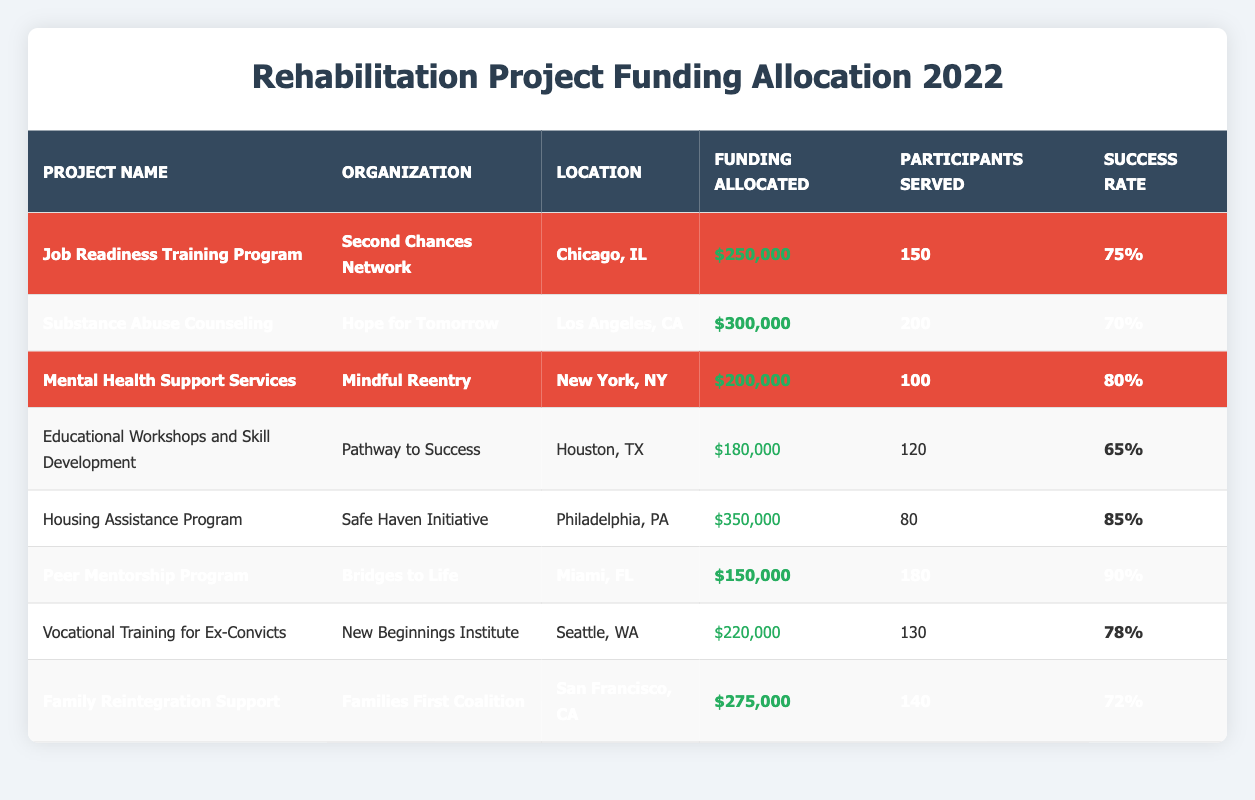What is the total funding allocated to the highlighted projects? The highlighted projects are: Job Readiness Training Program ($250,000), Substance Abuse Counseling ($300,000), Mental Health Support Services ($200,000), Peer Mentorship Program ($150,000), and Family Reintegration Support ($275,000). Adding these amounts gives: 250,000 + 300,000 + 200,000 + 150,000 + 275,000 = $1,175,000.
Answer: $1,175,000 Which project has the highest success rate? Looking at the success rates listed for all projects, the Peer Mentorship Program has the highest rate at 90%.
Answer: Peer Mentorship Program How many participants were served in total by the highlighted projects? The highlighted projects served: 150 (Job Readiness) + 200 (Substance Abuse) + 100 (Mental Health) + 180 (Peer Mentorship) + 140 (Family Reintegration) = 870 participants.
Answer: 870 participants True or False: The Housing Assistance Program has the lowest funding allocation among the projects listed. The funding allocated to the Housing Assistance Program is $350,000, which is the highest among all projects; therefore, the statement is false.
Answer: False What is the average success rate of all projects? The success rates are: 75%, 70%, 80%, 65%, 85%, 90%, 78%, and 72%. The total is 75 + 70 + 80 + 65 + 85 + 90 + 78 + 72 = 610%. There are 8 projects, so the average is 610% / 8 = 76.25%.
Answer: 76.25% Which organization served the most participants and how many did they serve? Comparing participants served: Hope for Tomorrow served 200, which is the highest among the projects listed.
Answer: Hope for Tomorrow, 200 participants What is the difference in funding between the highest and lowest funded highlighted projects? The highest funded highlighted project is Substance Abuse Counseling at $300,000 and the lowest is Peer Mentorship Program at $150,000. The difference is $300,000 - $150,000 = $150,000.
Answer: $150,000 Which project served the fewest participants overall? The Housing Assistance Program served the fewest participants, which is 80 in total.
Answer: Housing Assistance Program, 80 participants If we combine the funding of the two projects with the highest success rates, what would that total be? The highest success rates are for the Peer Mentorship Program (90%) and the Housing Assistance Program (85%). Their funding is $150,000 and $350,000 respectively, totaling: $150,000 + $350,000 = $500,000.
Answer: $500,000 